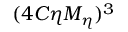<formula> <loc_0><loc_0><loc_500><loc_500>( 4 C \eta M _ { \eta } ) ^ { 3 }</formula> 